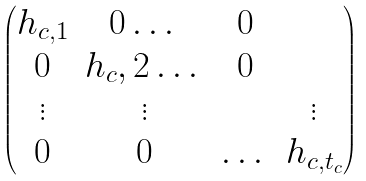<formula> <loc_0><loc_0><loc_500><loc_500>\begin{pmatrix} h _ { c , 1 } & 0 \dots & 0 \\ 0 & { h _ { c } , 2 } \dots & 0 \\ \vdots & \vdots & & \vdots \\ 0 & 0 & \dots & h _ { c , t _ { c } } \end{pmatrix}</formula> 